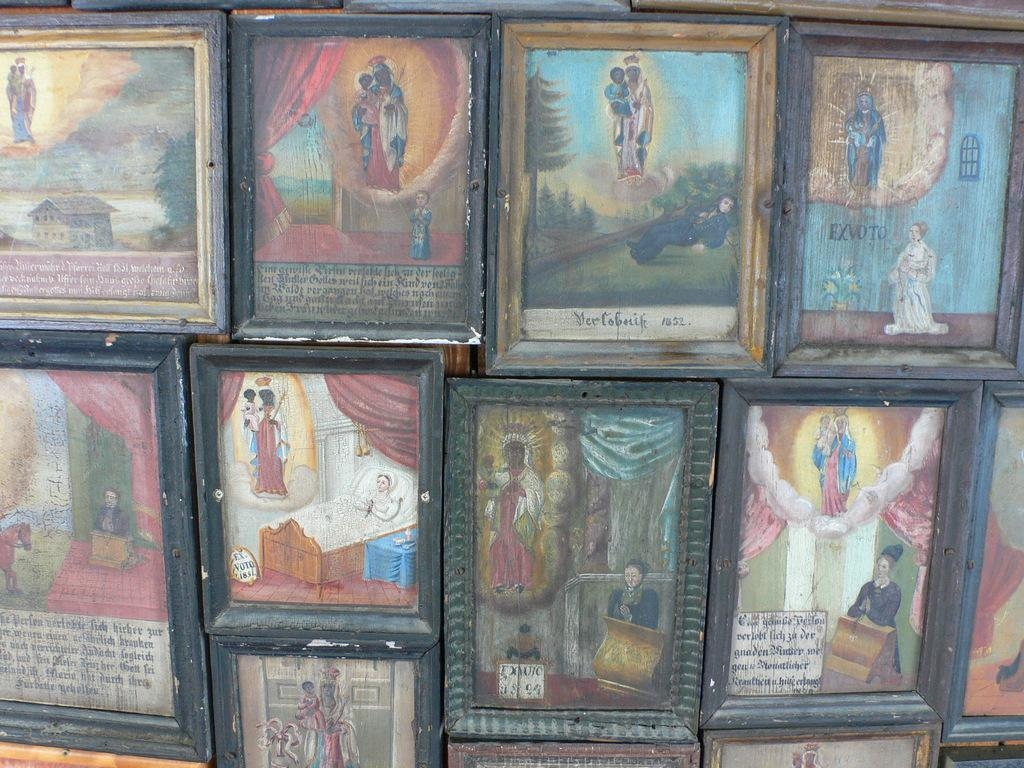<image>
Render a clear and concise summary of the photo. A grouping of pictures include the title Der Cobnik. 